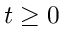Convert formula to latex. <formula><loc_0><loc_0><loc_500><loc_500>t \geq 0</formula> 